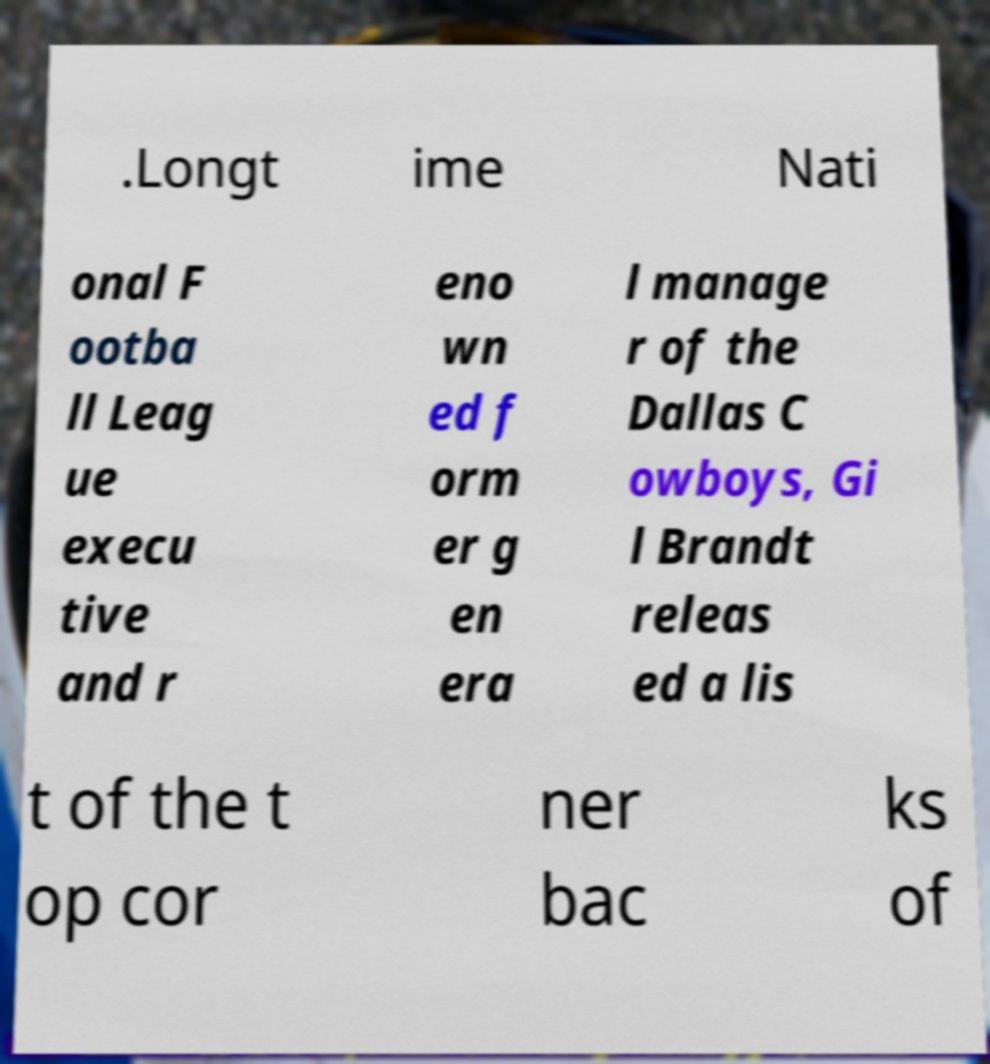Could you extract and type out the text from this image? .Longt ime Nati onal F ootba ll Leag ue execu tive and r eno wn ed f orm er g en era l manage r of the Dallas C owboys, Gi l Brandt releas ed a lis t of the t op cor ner bac ks of 